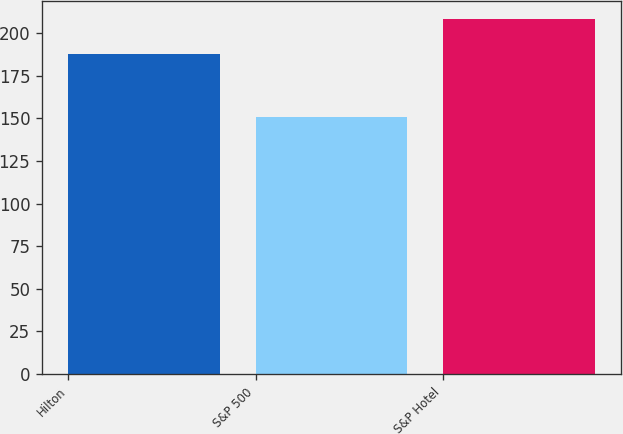Convert chart. <chart><loc_0><loc_0><loc_500><loc_500><bar_chart><fcel>Hilton<fcel>S&P 500<fcel>S&P Hotel<nl><fcel>187.58<fcel>150.58<fcel>208.58<nl></chart> 